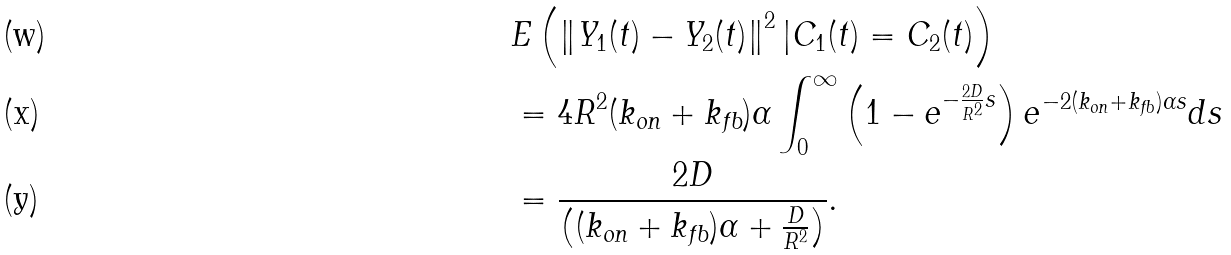Convert formula to latex. <formula><loc_0><loc_0><loc_500><loc_500>& E \left ( \left \| Y _ { 1 } ( t ) - Y _ { 2 } ( t ) \right \| ^ { 2 } | C _ { 1 } ( t ) = C _ { 2 } ( t ) \right ) \\ & = 4 R ^ { 2 } ( k _ { \text {on} } + k _ { \text {fb} } ) \alpha \int _ { 0 } ^ { \infty } \left ( 1 - e ^ { - \frac { 2 D } { R ^ { 2 } } s } \right ) e ^ { - 2 ( k _ { \text {on} } + k _ { \text {fb} } ) \alpha s } d s \\ & = \frac { 2 D } { \left ( ( k _ { \text {on} } + k _ { \text {fb} } ) \alpha + \frac { D } { R ^ { 2 } } \right ) } .</formula> 